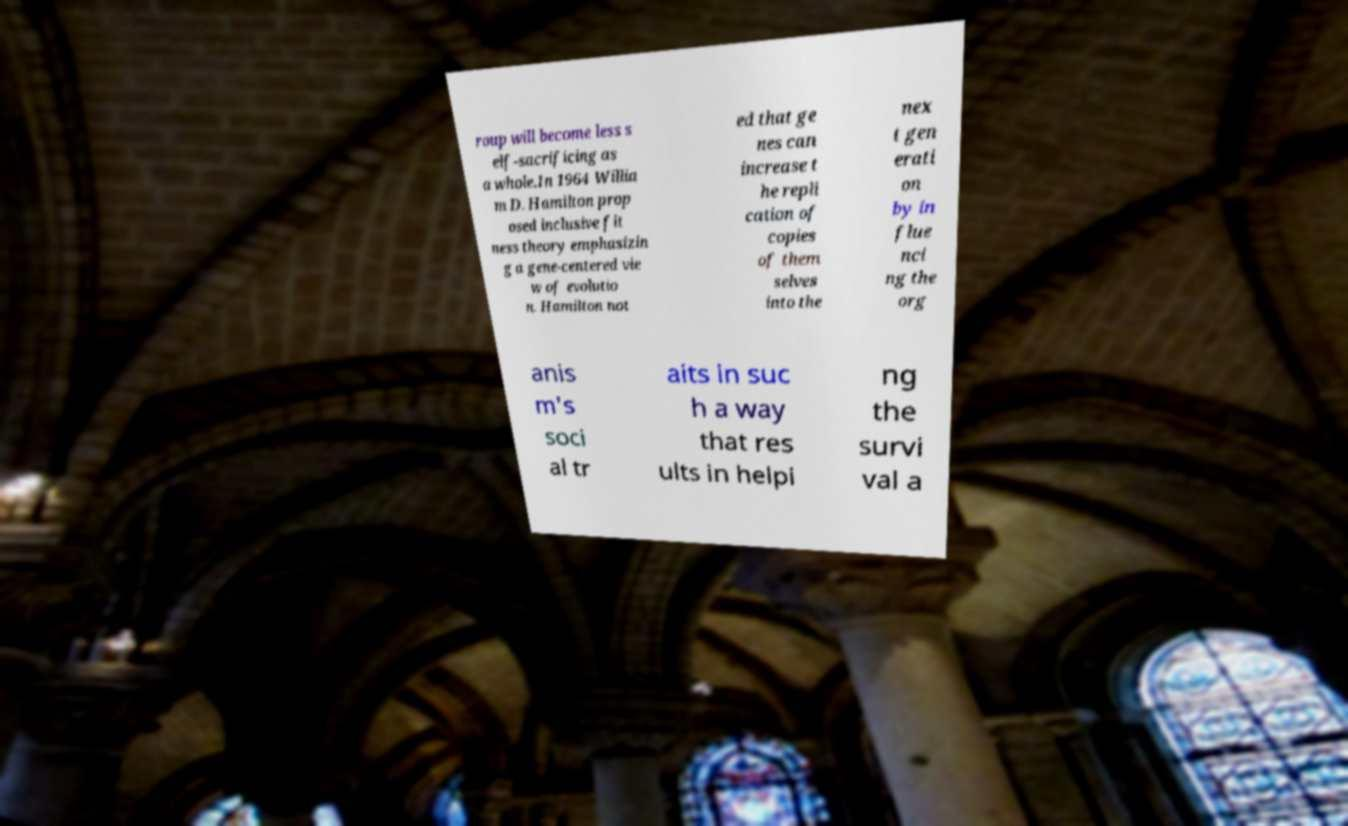There's text embedded in this image that I need extracted. Can you transcribe it verbatim? roup will become less s elf-sacrificing as a whole.In 1964 Willia m D. Hamilton prop osed inclusive fit ness theory emphasizin g a gene-centered vie w of evolutio n. Hamilton not ed that ge nes can increase t he repli cation of copies of them selves into the nex t gen erati on by in flue nci ng the org anis m's soci al tr aits in suc h a way that res ults in helpi ng the survi val a 